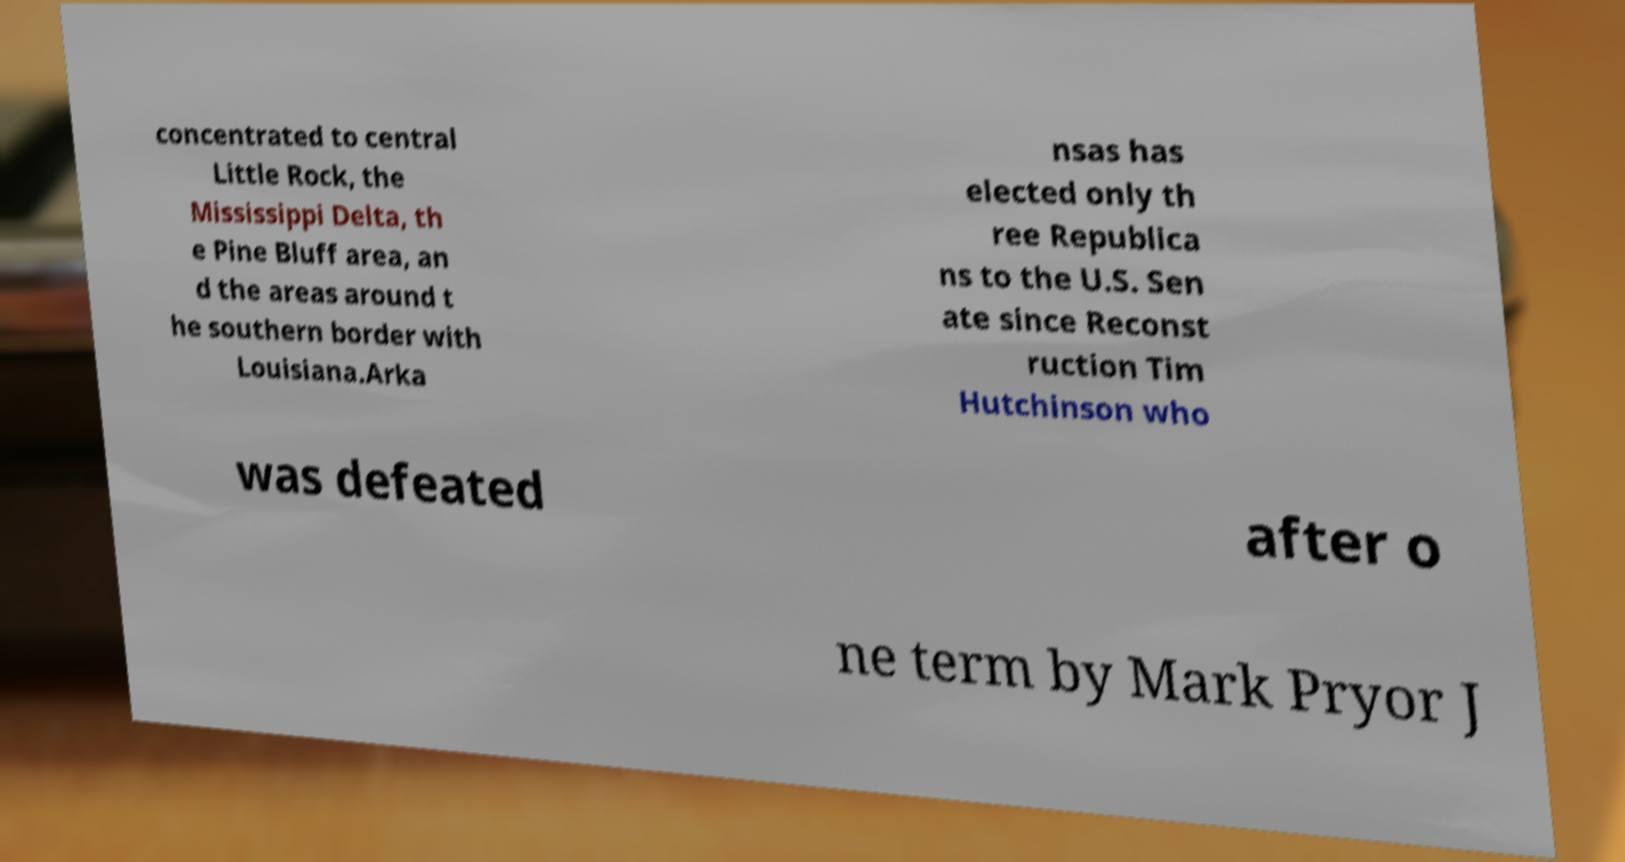Can you accurately transcribe the text from the provided image for me? concentrated to central Little Rock, the Mississippi Delta, th e Pine Bluff area, an d the areas around t he southern border with Louisiana.Arka nsas has elected only th ree Republica ns to the U.S. Sen ate since Reconst ruction Tim Hutchinson who was defeated after o ne term by Mark Pryor J 